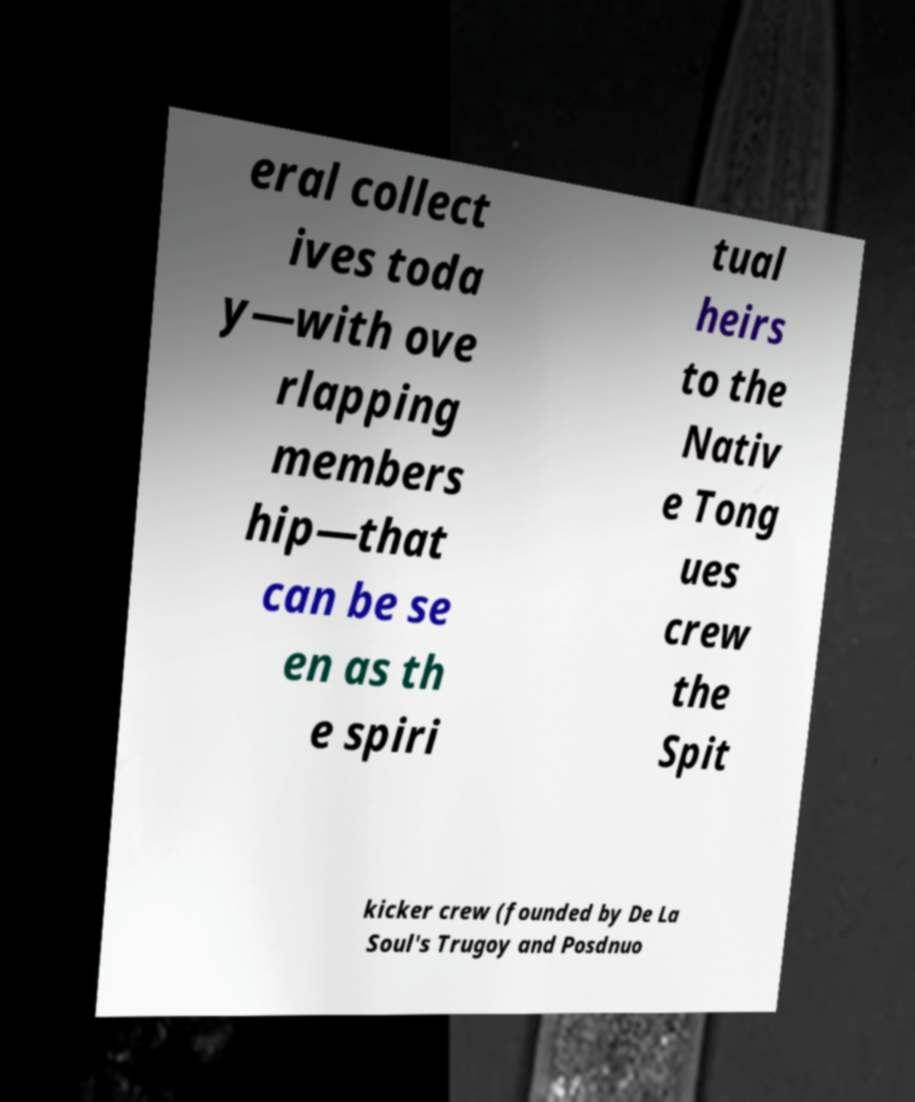Could you extract and type out the text from this image? eral collect ives toda y—with ove rlapping members hip—that can be se en as th e spiri tual heirs to the Nativ e Tong ues crew the Spit kicker crew (founded by De La Soul's Trugoy and Posdnuo 